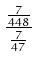Convert formula to latex. <formula><loc_0><loc_0><loc_500><loc_500>\frac { \frac { 7 } { 4 4 8 } } { \frac { 7 } { 4 7 } }</formula> 